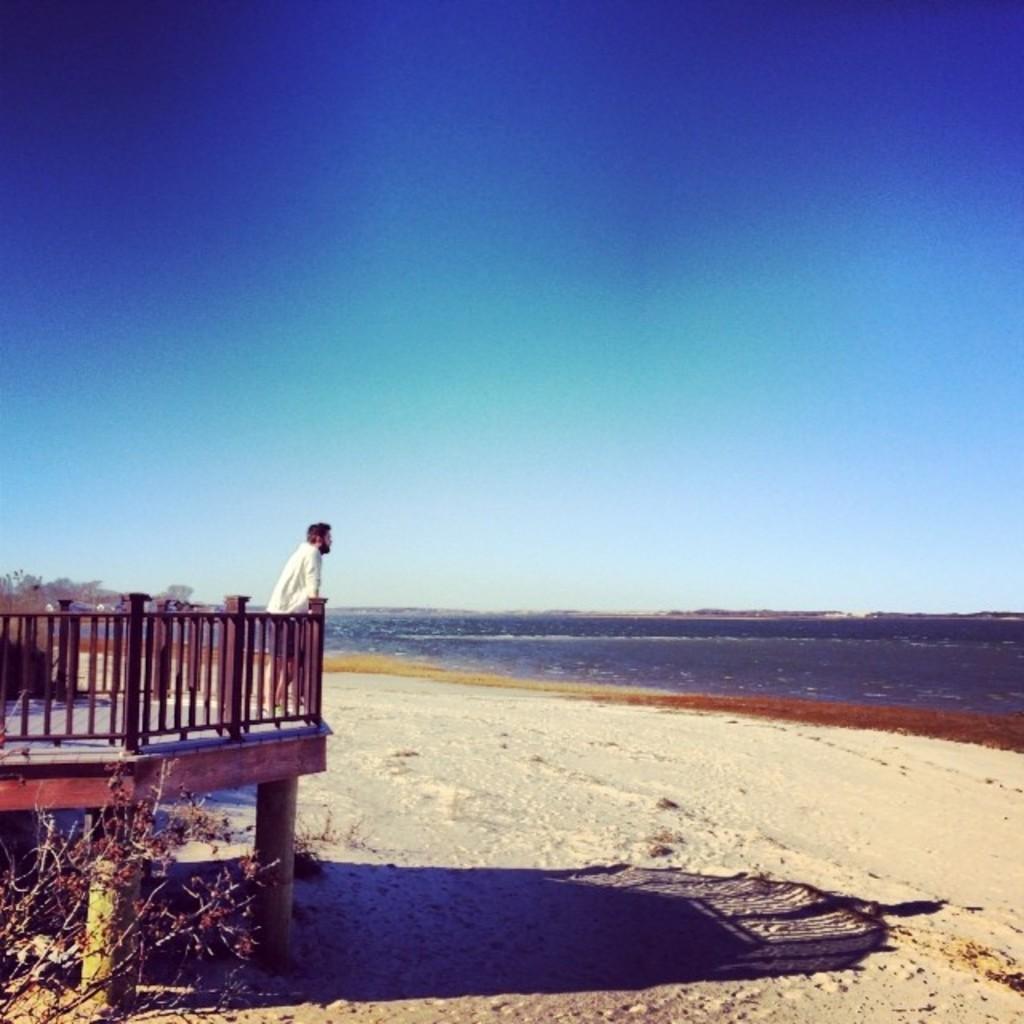Could you give a brief overview of what you see in this image? In this image I can see a man is standing on a wooden surface. Here I can see the man is wearing white clothes. On the left side I can see a plant. In the background I can see water and the sky. 